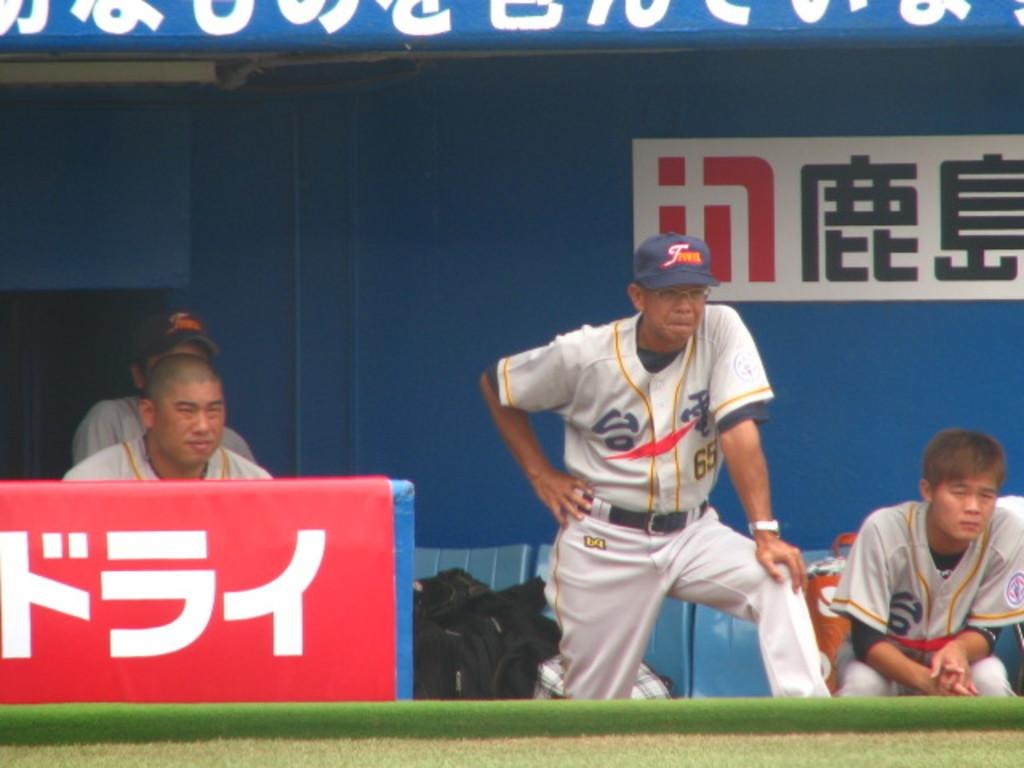<image>
Share a concise interpretation of the image provided. A baseball team is in the dug out and one of their uniforms has the number 65. 